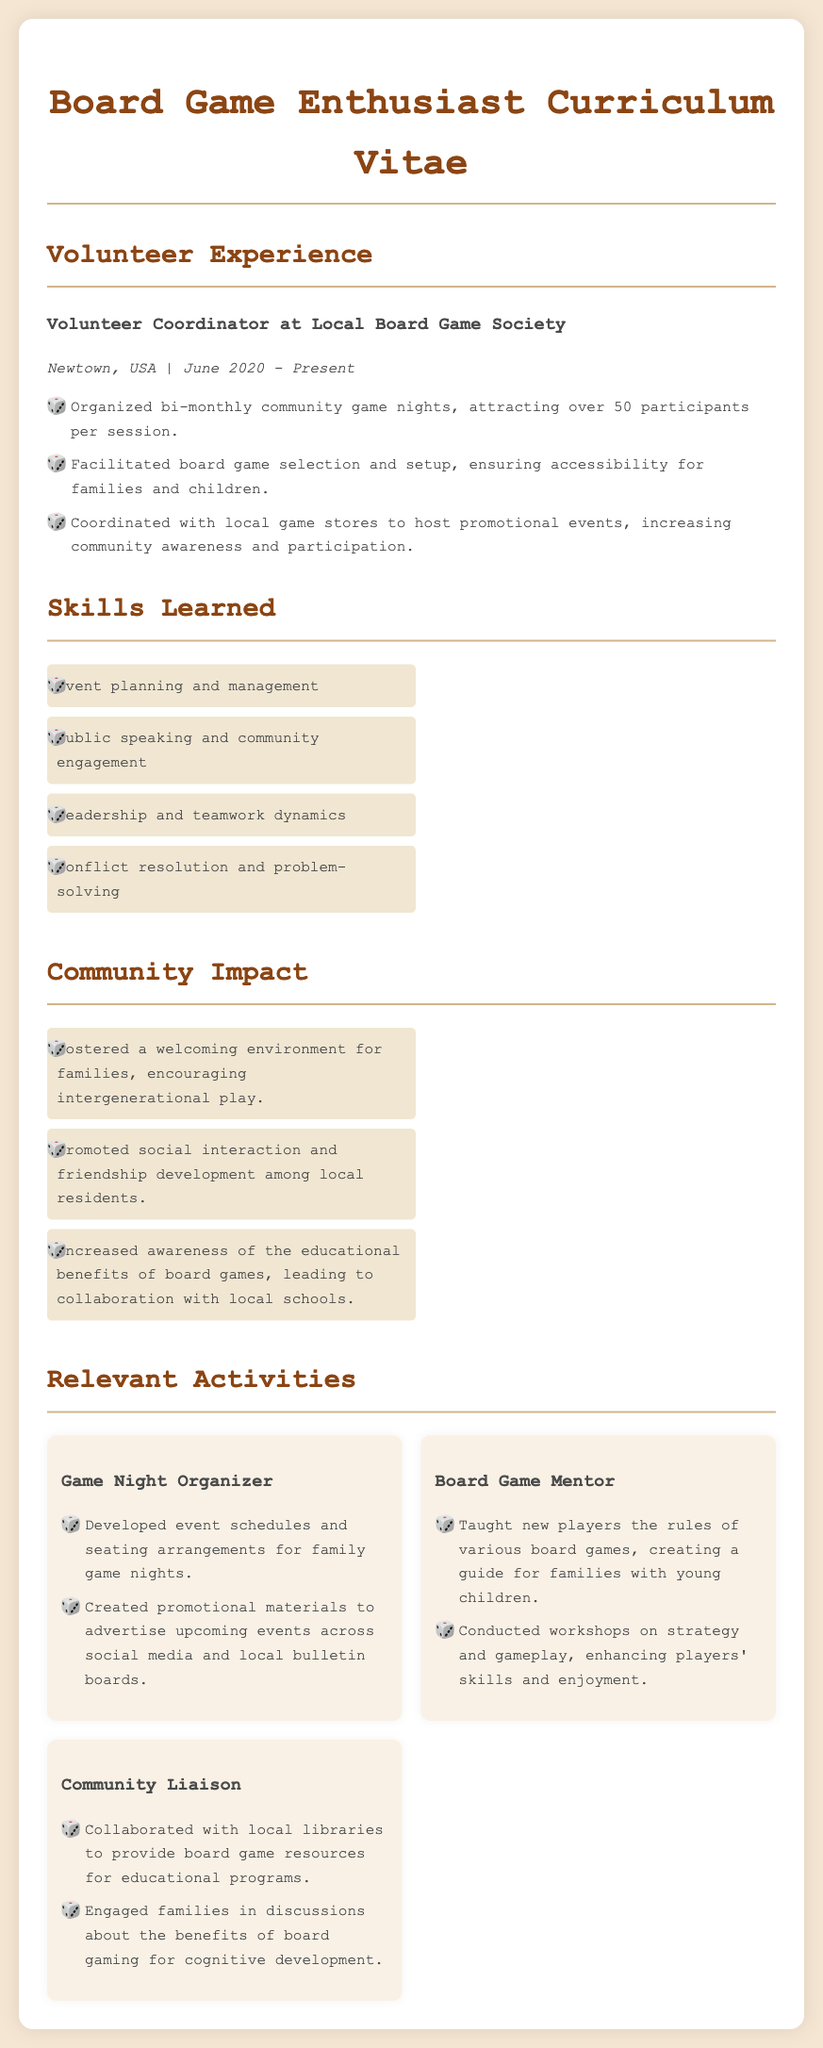What is the role held in the local board game community? The document mentions the title as Volunteer Coordinator.
Answer: Volunteer Coordinator When did the volunteer experience start? The start date of the volunteer experience is listed as June 2020.
Answer: June 2020 How many participants were attracted to the bi-monthly community game nights? The document states that over 50 participants attended each session.
Answer: over 50 What skill related to public interaction was learned? The document lists public speaking and community engagement as a learned skill.
Answer: public speaking and community engagement What was one impact of the community involvement? The document highlights that it fostered a welcoming environment for families.
Answer: a welcoming environment for families Which local organizations were collaborated with for resources? The document indicates collaboration with local libraries to provide resources.
Answer: local libraries What type of events were organized bi-monthly? The document specifies community game nights as the type of events organized.
Answer: community game nights What educational benefits were promoted through board games? The document mentions collaboration with local schools to highlight educational benefits.
Answer: collaboration with local schools 